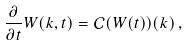<formula> <loc_0><loc_0><loc_500><loc_500>\frac { \partial } { \partial t } W ( k , t ) = \mathcal { C } ( W ( t ) ) ( k ) \, ,</formula> 